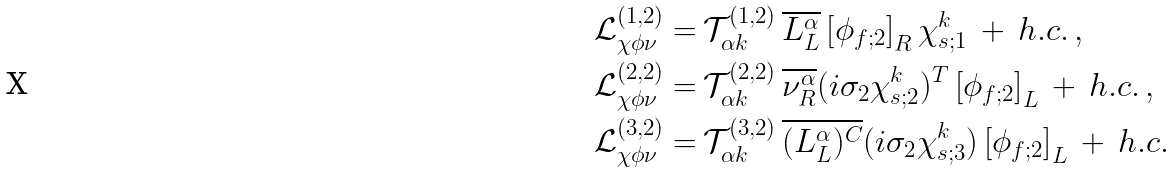Convert formula to latex. <formula><loc_0><loc_0><loc_500><loc_500>\mathcal { L } ^ { ( 1 , 2 ) } _ { \chi \phi \nu } = & \, \mathcal { T } ^ { ( 1 , 2 ) } _ { \alpha k } \, \overline { L ^ { \alpha } _ { L } } \left [ \phi _ { f ; 2 } \right ] _ { R } \chi ^ { k } _ { s ; 1 } \, + \, h . c . \, , \\ \mathcal { L } ^ { ( 2 , 2 ) } _ { \chi \phi \nu } = & \, \mathcal { T } ^ { ( 2 , 2 ) } _ { \alpha k } \, \overline { \nu ^ { \alpha } _ { R } } ( i \sigma _ { 2 } \chi ^ { k } _ { s ; 2 } ) ^ { T } \left [ \phi _ { f ; 2 } \right ] _ { L } \, + \, h . c . \, , \\ \mathcal { L } ^ { ( 3 , 2 ) } _ { \chi \phi \nu } = & \, \mathcal { T } ^ { ( 3 , 2 ) } _ { \alpha k } \, \overline { ( L ^ { \alpha } _ { L } ) ^ { C } } ( i \sigma _ { 2 } \chi ^ { k } _ { s ; 3 } ) \left [ \phi _ { f ; 2 } \right ] _ { L } \, + \, h . c .</formula> 